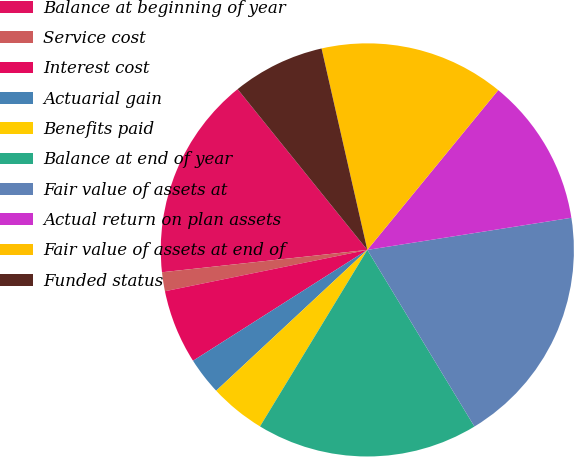<chart> <loc_0><loc_0><loc_500><loc_500><pie_chart><fcel>Balance at beginning of year<fcel>Service cost<fcel>Interest cost<fcel>Actuarial gain<fcel>Benefits paid<fcel>Balance at end of year<fcel>Fair value of assets at<fcel>Actual return on plan assets<fcel>Fair value of assets at end of<fcel>Funded status<nl><fcel>15.92%<fcel>1.48%<fcel>5.81%<fcel>2.92%<fcel>4.37%<fcel>17.37%<fcel>18.81%<fcel>11.59%<fcel>14.48%<fcel>7.25%<nl></chart> 